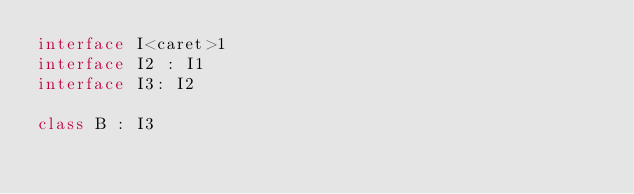Convert code to text. <code><loc_0><loc_0><loc_500><loc_500><_Kotlin_>interface I<caret>1
interface I2 : I1
interface I3: I2

class B : I3
</code> 